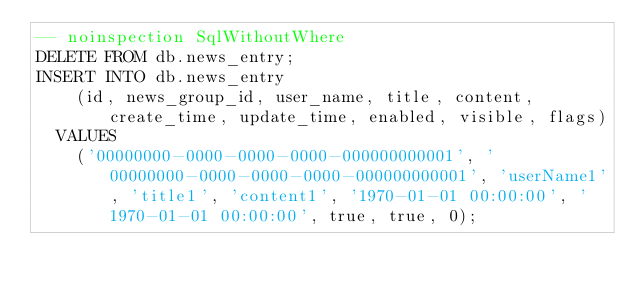<code> <loc_0><loc_0><loc_500><loc_500><_SQL_>-- noinspection SqlWithoutWhere
DELETE FROM db.news_entry;
INSERT INTO db.news_entry
    (id, news_group_id, user_name, title, content, create_time, update_time, enabled, visible, flags)
  VALUES
    ('00000000-0000-0000-0000-000000000001', '00000000-0000-0000-0000-000000000001', 'userName1', 'title1', 'content1', '1970-01-01 00:00:00', '1970-01-01 00:00:00', true, true, 0);</code> 